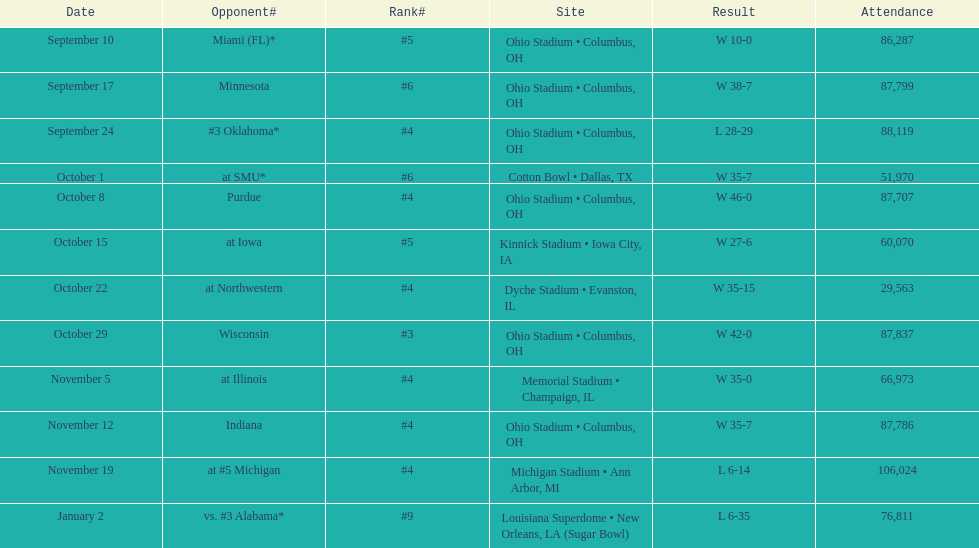Which was the most recent game with an attendance of less than 30,000 individuals? October 22. 